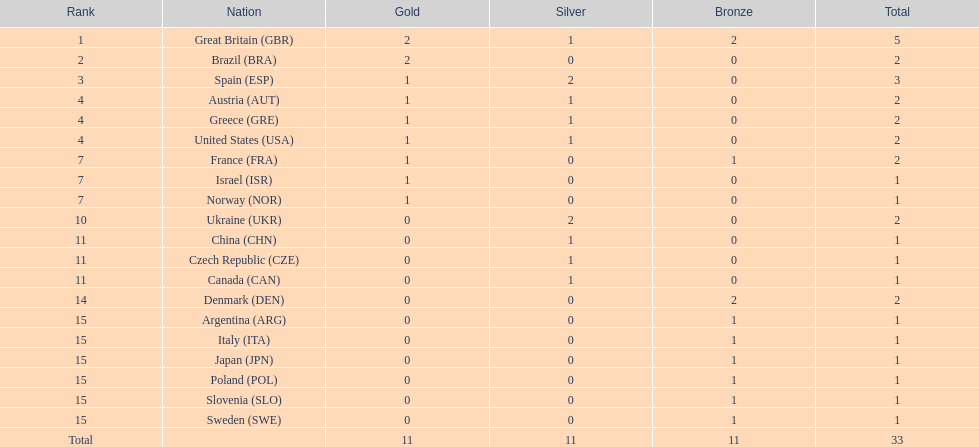In how many nations have athletes secured a minimum of one gold and one silver medal? 5. 